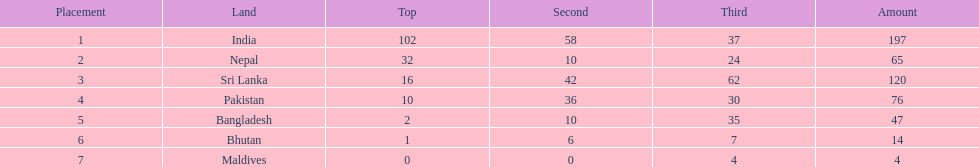What was the number of silver medals won by pakistan? 36. 